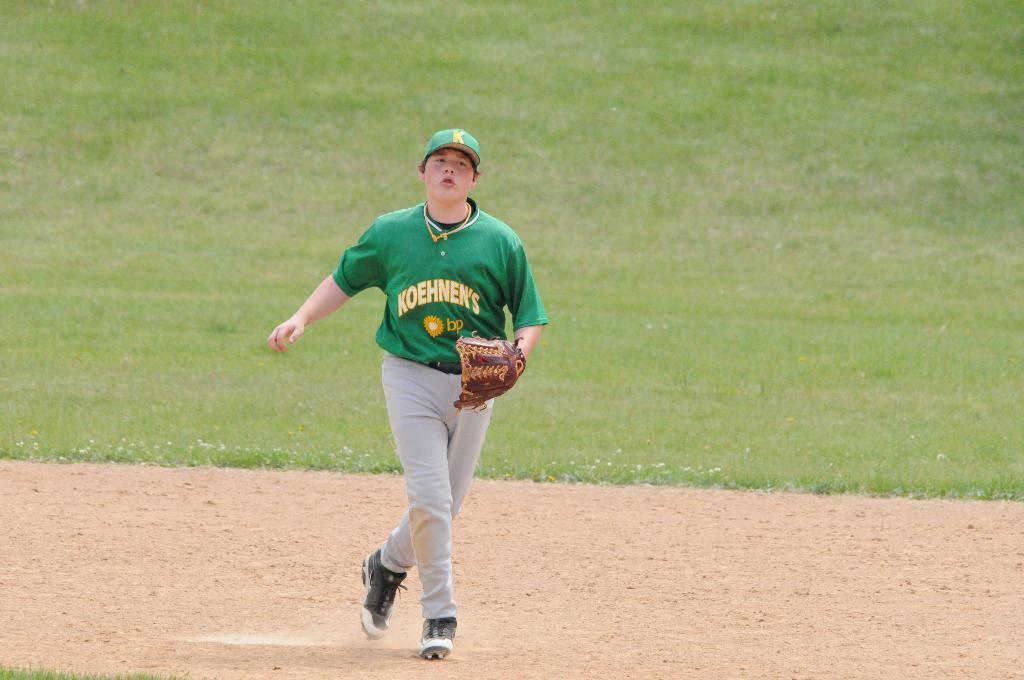<image>
Describe the image concisely. player in green for koehnen's bp looking up for the ball 